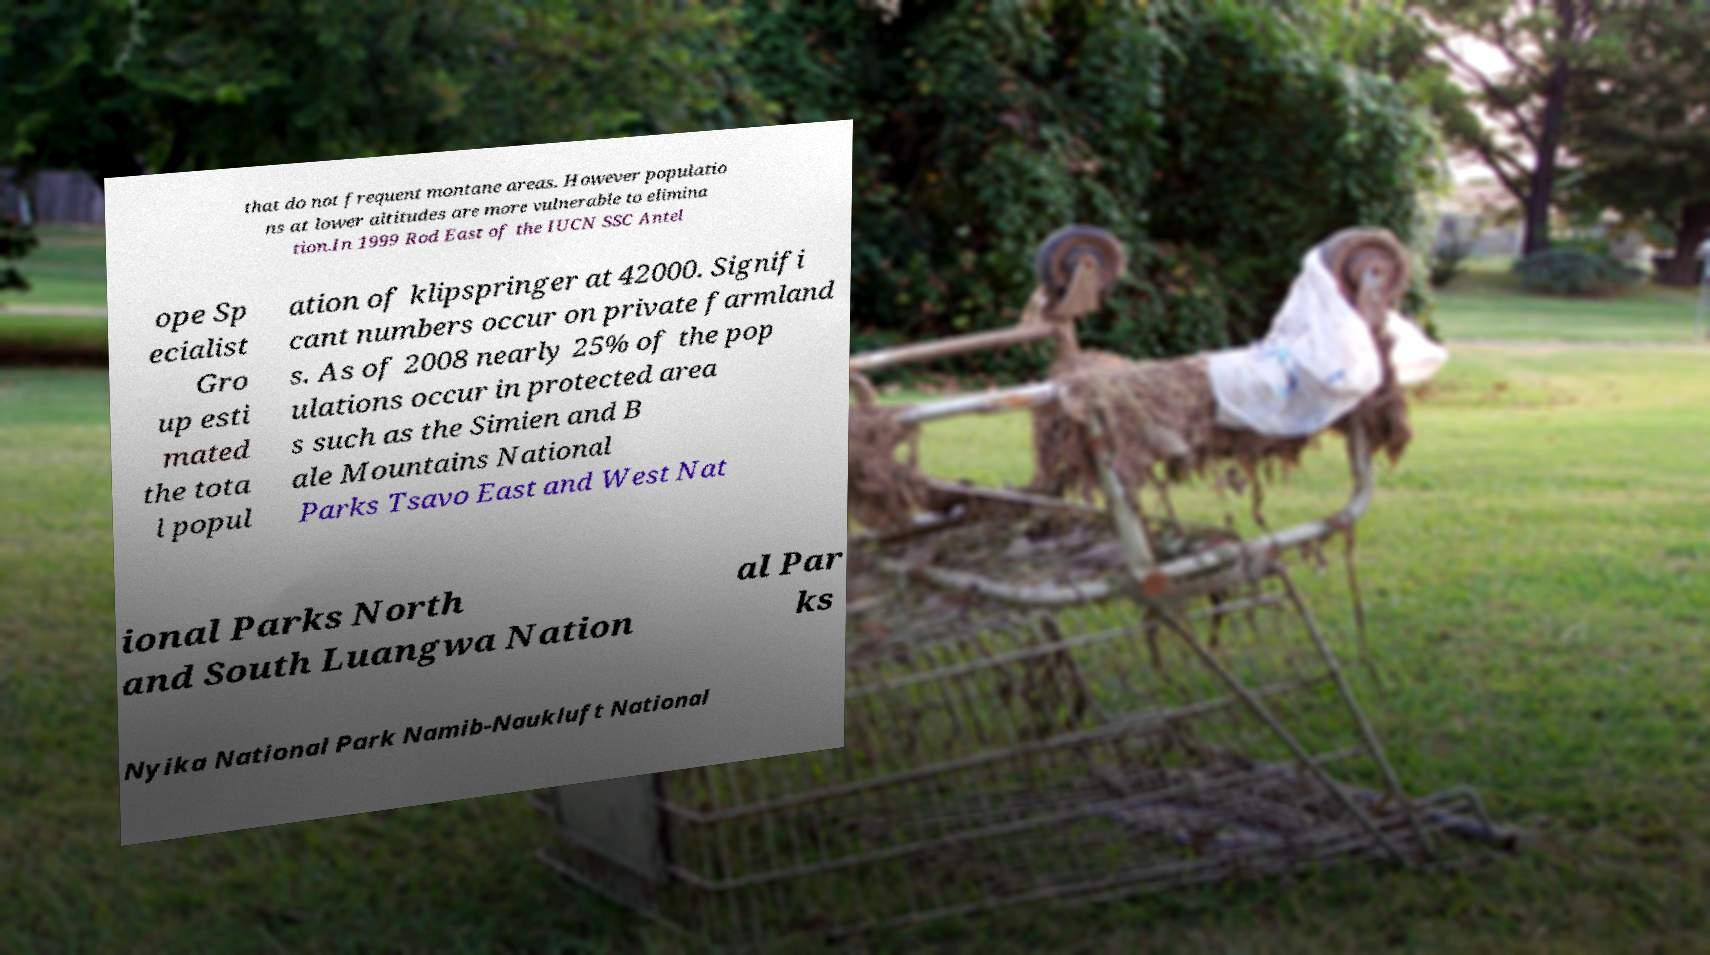Can you accurately transcribe the text from the provided image for me? that do not frequent montane areas. However populatio ns at lower altitudes are more vulnerable to elimina tion.In 1999 Rod East of the IUCN SSC Antel ope Sp ecialist Gro up esti mated the tota l popul ation of klipspringer at 42000. Signifi cant numbers occur on private farmland s. As of 2008 nearly 25% of the pop ulations occur in protected area s such as the Simien and B ale Mountains National Parks Tsavo East and West Nat ional Parks North and South Luangwa Nation al Par ks Nyika National Park Namib-Naukluft National 